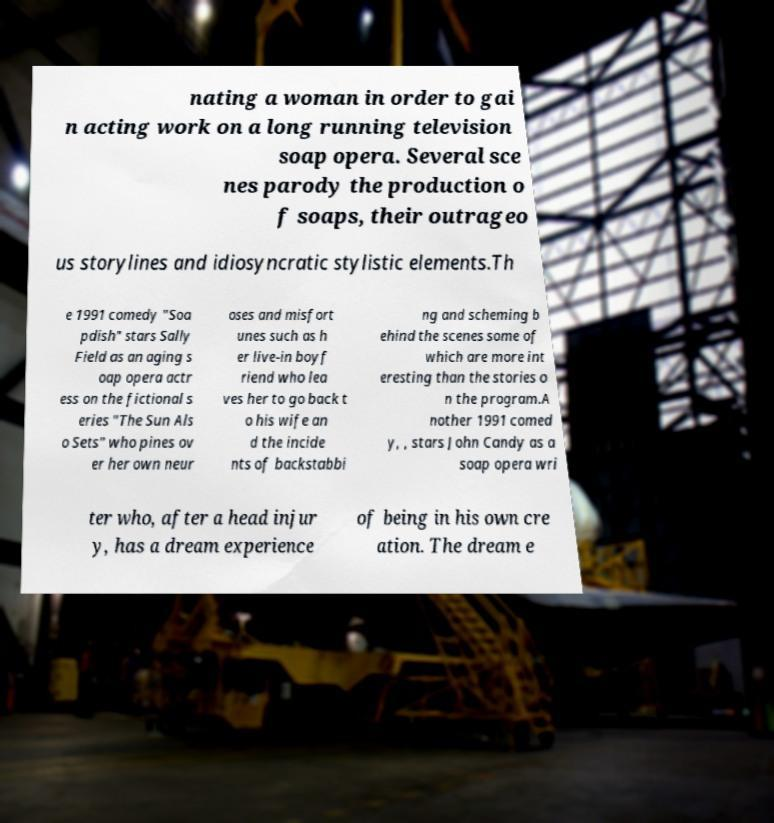Please read and relay the text visible in this image. What does it say? nating a woman in order to gai n acting work on a long running television soap opera. Several sce nes parody the production o f soaps, their outrageo us storylines and idiosyncratic stylistic elements.Th e 1991 comedy "Soa pdish" stars Sally Field as an aging s oap opera actr ess on the fictional s eries "The Sun Als o Sets" who pines ov er her own neur oses and misfort unes such as h er live-in boyf riend who lea ves her to go back t o his wife an d the incide nts of backstabbi ng and scheming b ehind the scenes some of which are more int eresting than the stories o n the program.A nother 1991 comed y, , stars John Candy as a soap opera wri ter who, after a head injur y, has a dream experience of being in his own cre ation. The dream e 